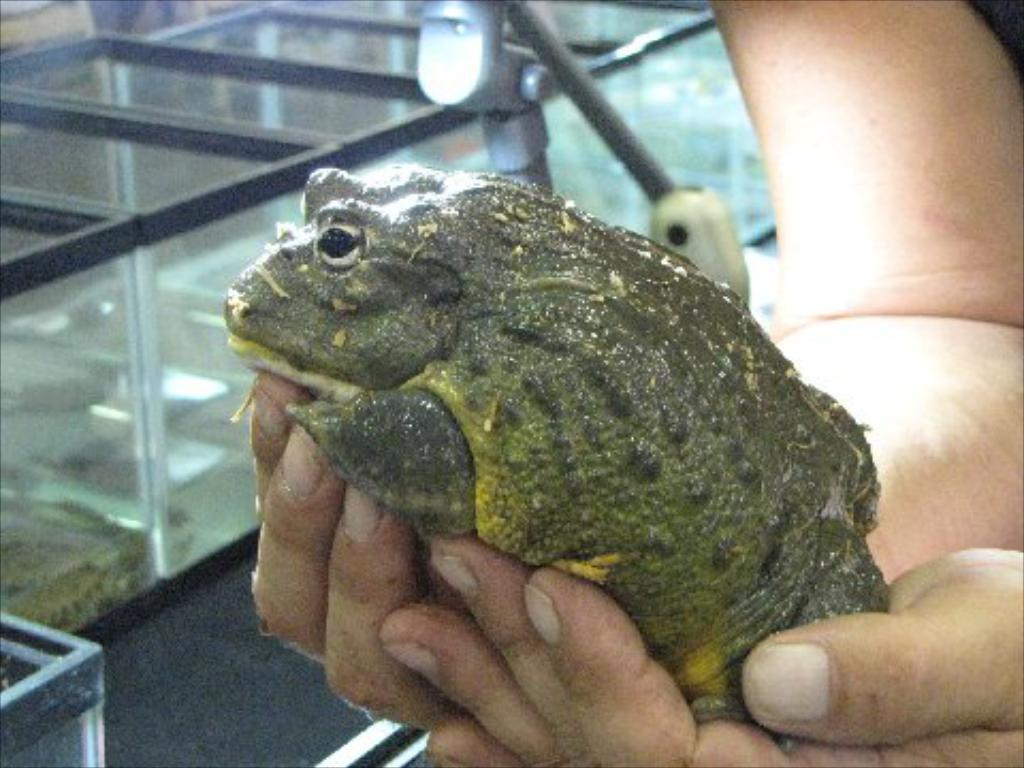What is the human hand holding in the image? The human hand is holding a frog in the image. What other objects can be seen in the image? There are boxes in the image. What does the frog need in the image? The image does not provide information about what the frog needs, as it only shows the frog being held by a human hand. Is the frog crying in the image? There is no indication in the image that the frog is crying. 